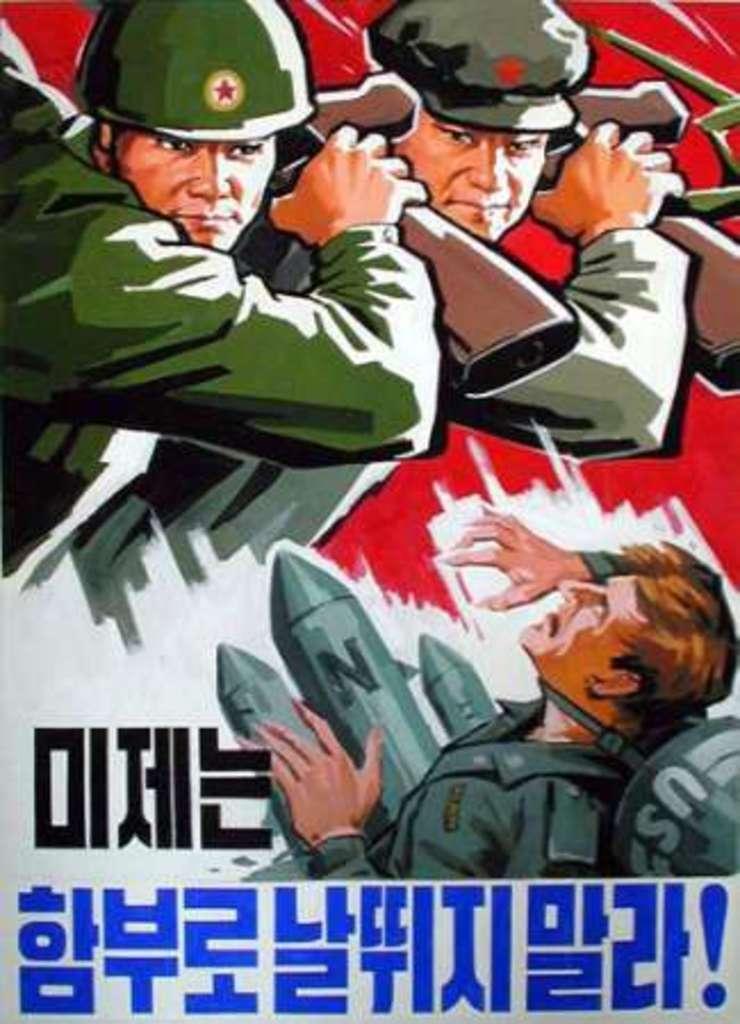In one or two sentences, can you explain what this image depicts? In this image, we can see a poster of a few people. Among them, some people are holding some objects. We can also see some text. 